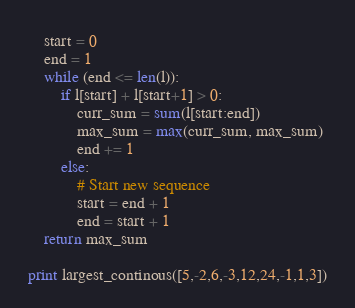<code> <loc_0><loc_0><loc_500><loc_500><_Python_>    start = 0
    end = 1
    while (end <= len(l)):
        if l[start] + l[start+1] > 0:
            curr_sum = sum(l[start:end])
            max_sum = max(curr_sum, max_sum)
            end += 1
        else:
            # Start new sequence
            start = end + 1
            end = start + 1
    return max_sum

print largest_continous([5,-2,6,-3,12,24,-1,1,3])
</code> 